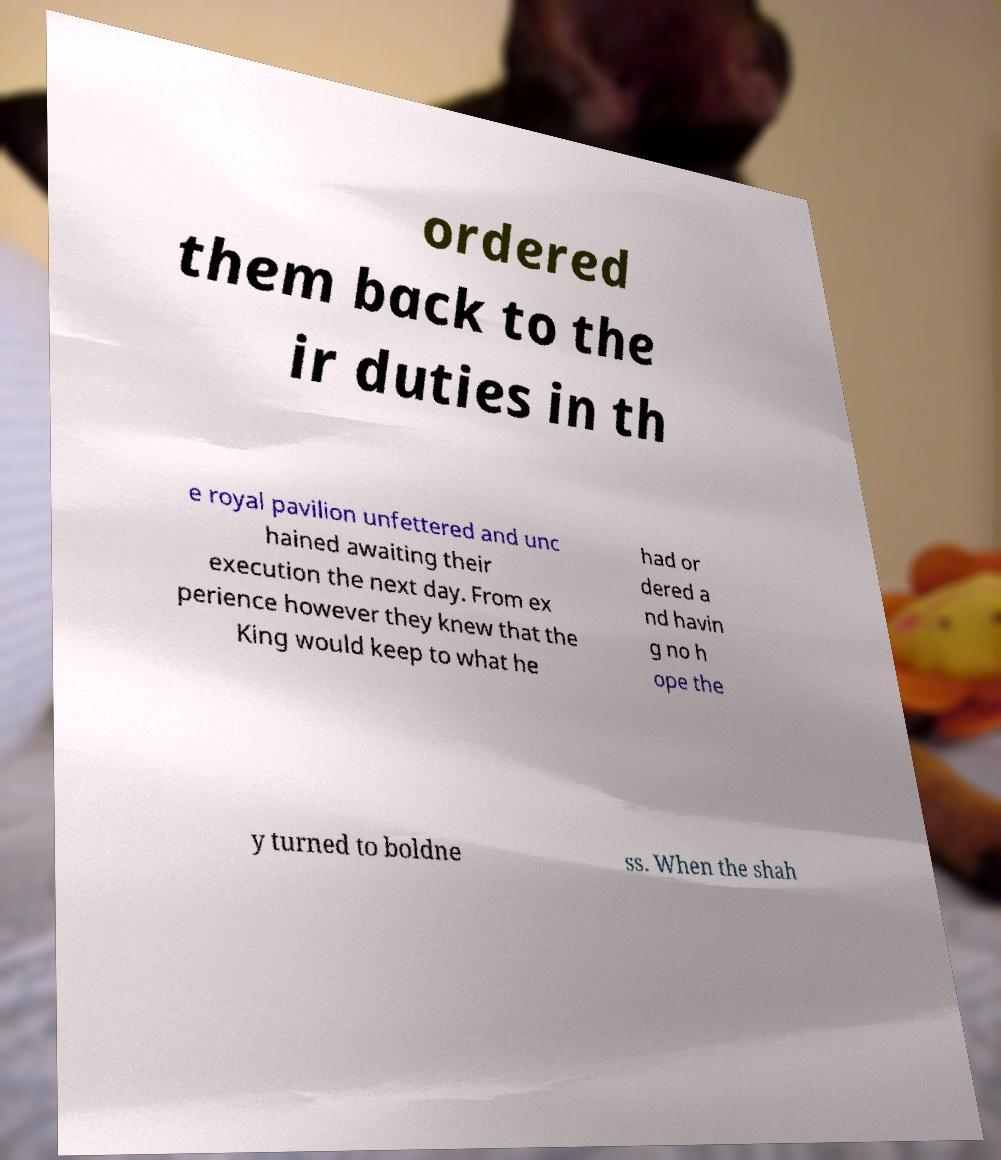Could you assist in decoding the text presented in this image and type it out clearly? ordered them back to the ir duties in th e royal pavilion unfettered and unc hained awaiting their execution the next day. From ex perience however they knew that the King would keep to what he had or dered a nd havin g no h ope the y turned to boldne ss. When the shah 